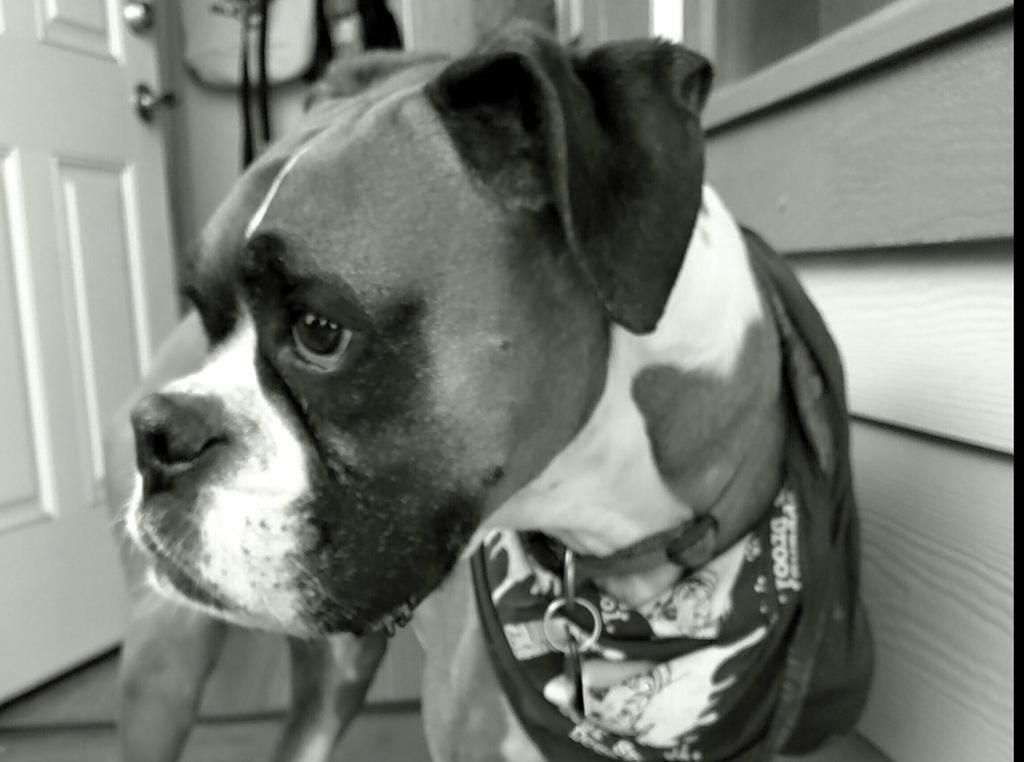What is the color scheme of the image? The image is black and white. What animal can be seen in the image? There is a dog in the image. Where is the dog located in the image? The dog is standing on the floor. What type of apparel is the dog wearing in the image? There is no apparel visible on the dog in the image, as it is a black and white photograph. What food is the dog eating in the image? There is no food present in the image; the dog is simply standing on the floor. 